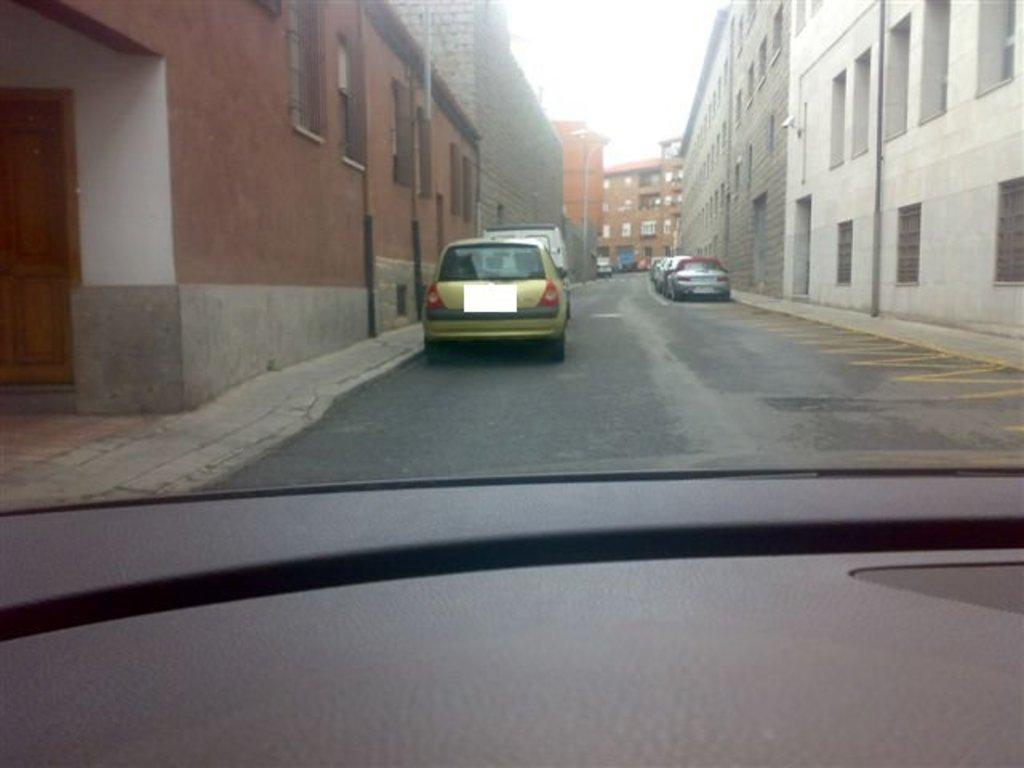What can be seen on both sides of the road in the image? There are cars parked on either side of the road. What type of structures are visible in the image? There are buildings visible in the image. What is visible in the background of the image? The sky is visible in the background of the image. How does the bee fly through the buildings in the image? There are no bees present in the image; it only features cars parked on either side of the road and buildings. 